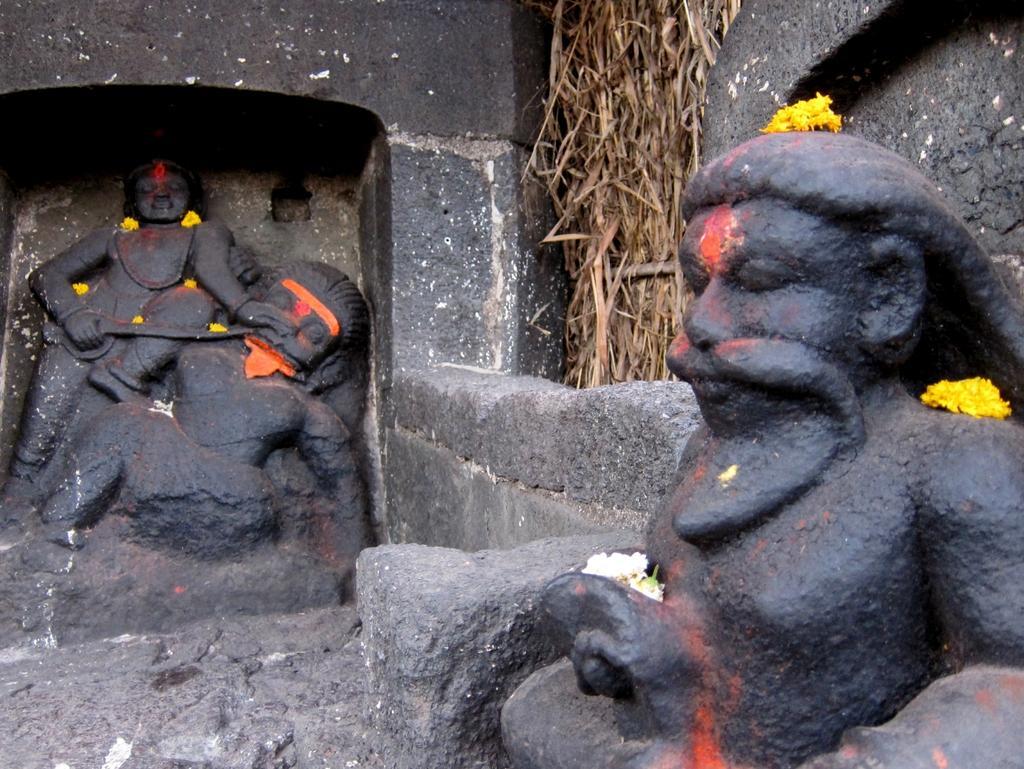In one or two sentences, can you explain what this image depicts? In this image, we can see some Idols. We can see the wall and some dried grass. 